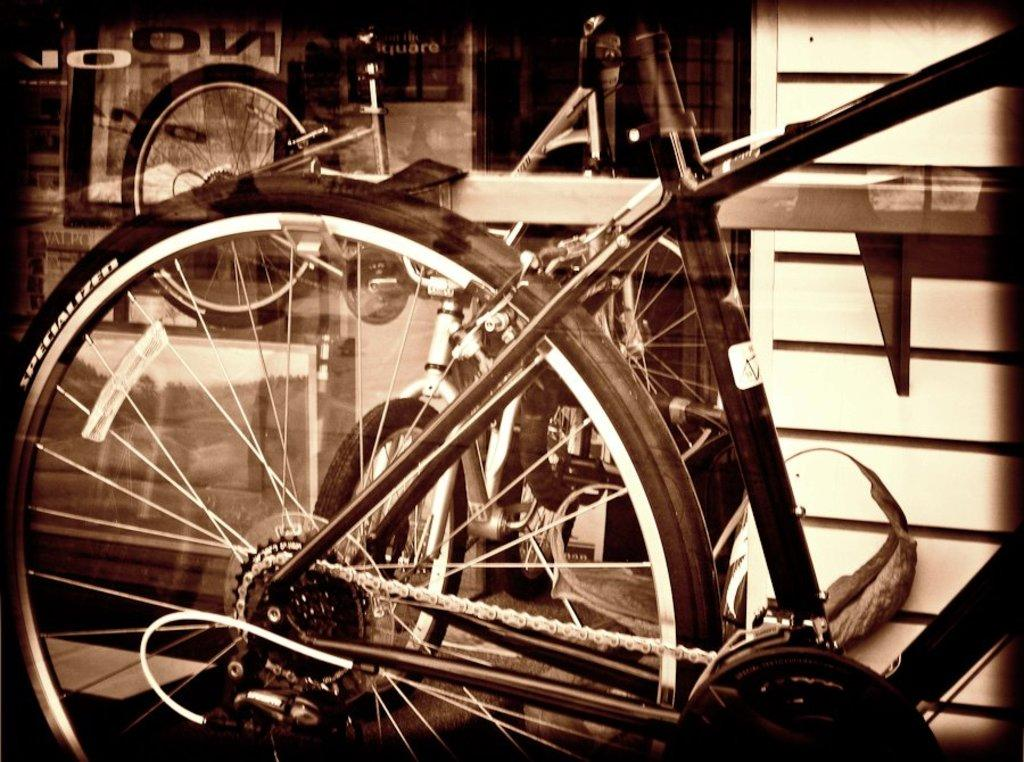What type of vehicles are present in the image? There are bicycles in the image. What type of milk is being poured from the middle of the bicycle in the image? There is no milk or pouring action present in the image; it only features bicycles. 